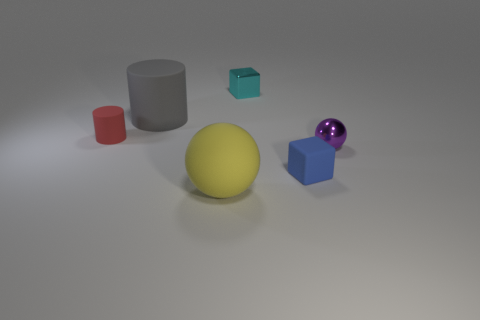What shape is the small matte thing that is on the right side of the tiny metallic thing behind the gray cylinder? cube 